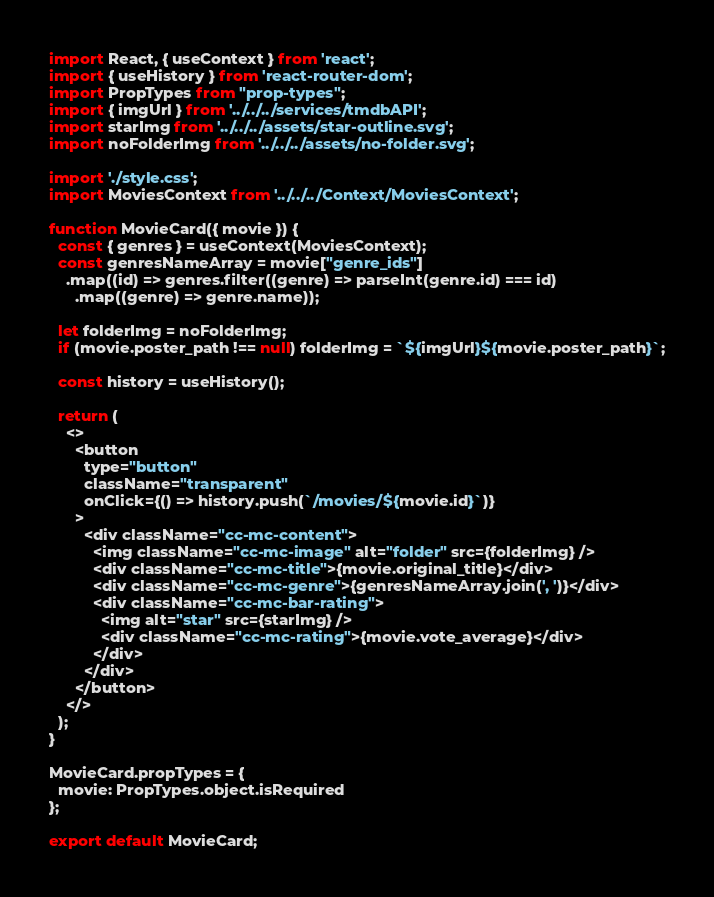<code> <loc_0><loc_0><loc_500><loc_500><_JavaScript_>import React, { useContext } from 'react';
import { useHistory } from 'react-router-dom';
import PropTypes from "prop-types";
import { imgUrl } from '../../../services/tmdbAPI';
import starImg from '../../../assets/star-outline.svg';
import noFolderImg from '../../../assets/no-folder.svg';

import './style.css';
import MoviesContext from '../../../Context/MoviesContext';

function MovieCard({ movie }) {
  const { genres } = useContext(MoviesContext);
  const genresNameArray = movie["genre_ids"]
    .map((id) => genres.filter((genre) => parseInt(genre.id) === id)
      .map((genre) => genre.name));

  let folderImg = noFolderImg;
  if (movie.poster_path !== null) folderImg = `${imgUrl}${movie.poster_path}`;

  const history = useHistory();

  return (
    <>
      <button
        type="button"
        className="transparent"
        onClick={() => history.push(`/movies/${movie.id}`)}
      >
        <div className="cc-mc-content">
          <img className="cc-mc-image" alt="folder" src={folderImg} />
          <div className="cc-mc-title">{movie.original_title}</div>
          <div className="cc-mc-genre">{genresNameArray.join(', ')}</div>
          <div className="cc-mc-bar-rating">
            <img alt="star" src={starImg} />
            <div className="cc-mc-rating">{movie.vote_average}</div>
          </div>
        </div>
      </button>
    </>
  );
}

MovieCard.propTypes = {
  movie: PropTypes.object.isRequired
};

export default MovieCard;</code> 